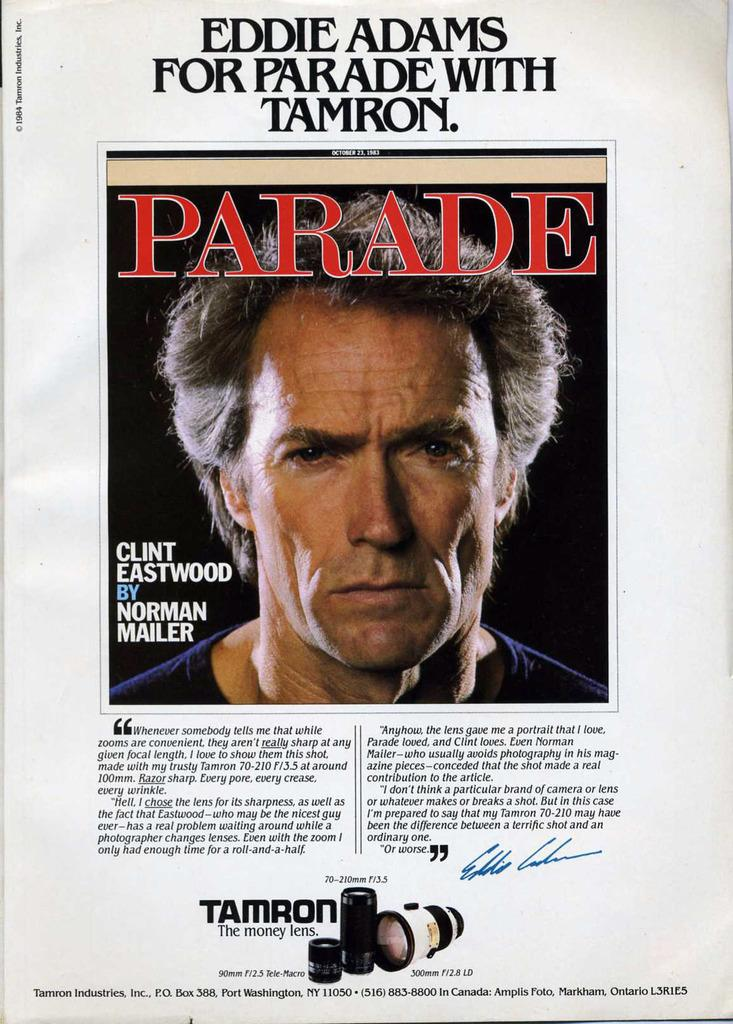What is present on the paper in the image? The paper contains an image of a man and text. Can you describe the image on the paper? The image on the paper is of a man. What else can be found on the paper besides the image? There is text on the paper. What sound does the bucket make when it quivers in the image? There is no bucket present in the image, so it cannot make any sound or quiver. 